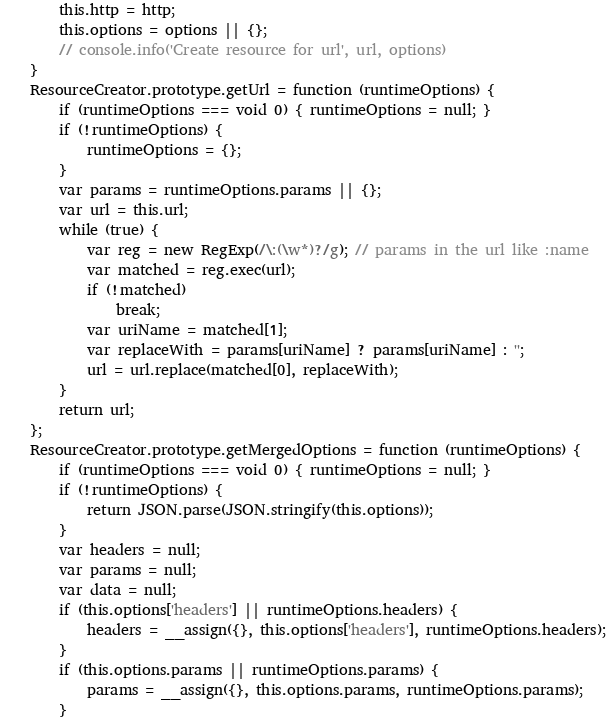Convert code to text. <code><loc_0><loc_0><loc_500><loc_500><_JavaScript_>        this.http = http;
        this.options = options || {};
        // console.info('Create resource for url', url, options)
    }
    ResourceCreator.prototype.getUrl = function (runtimeOptions) {
        if (runtimeOptions === void 0) { runtimeOptions = null; }
        if (!runtimeOptions) {
            runtimeOptions = {};
        }
        var params = runtimeOptions.params || {};
        var url = this.url;
        while (true) {
            var reg = new RegExp(/\:(\w*)?/g); // params in the url like :name
            var matched = reg.exec(url);
            if (!matched)
                break;
            var uriName = matched[1];
            var replaceWith = params[uriName] ? params[uriName] : '';
            url = url.replace(matched[0], replaceWith);
        }
        return url;
    };
    ResourceCreator.prototype.getMergedOptions = function (runtimeOptions) {
        if (runtimeOptions === void 0) { runtimeOptions = null; }
        if (!runtimeOptions) {
            return JSON.parse(JSON.stringify(this.options));
        }
        var headers = null;
        var params = null;
        var data = null;
        if (this.options['headers'] || runtimeOptions.headers) {
            headers = __assign({}, this.options['headers'], runtimeOptions.headers);
        }
        if (this.options.params || runtimeOptions.params) {
            params = __assign({}, this.options.params, runtimeOptions.params);
        }</code> 